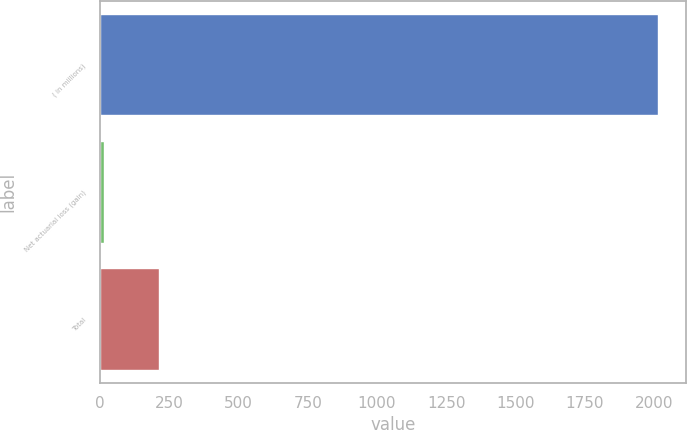<chart> <loc_0><loc_0><loc_500><loc_500><bar_chart><fcel>( in millions)<fcel>Net actuarial loss (gain)<fcel>Total<nl><fcel>2015<fcel>13.2<fcel>213.38<nl></chart> 